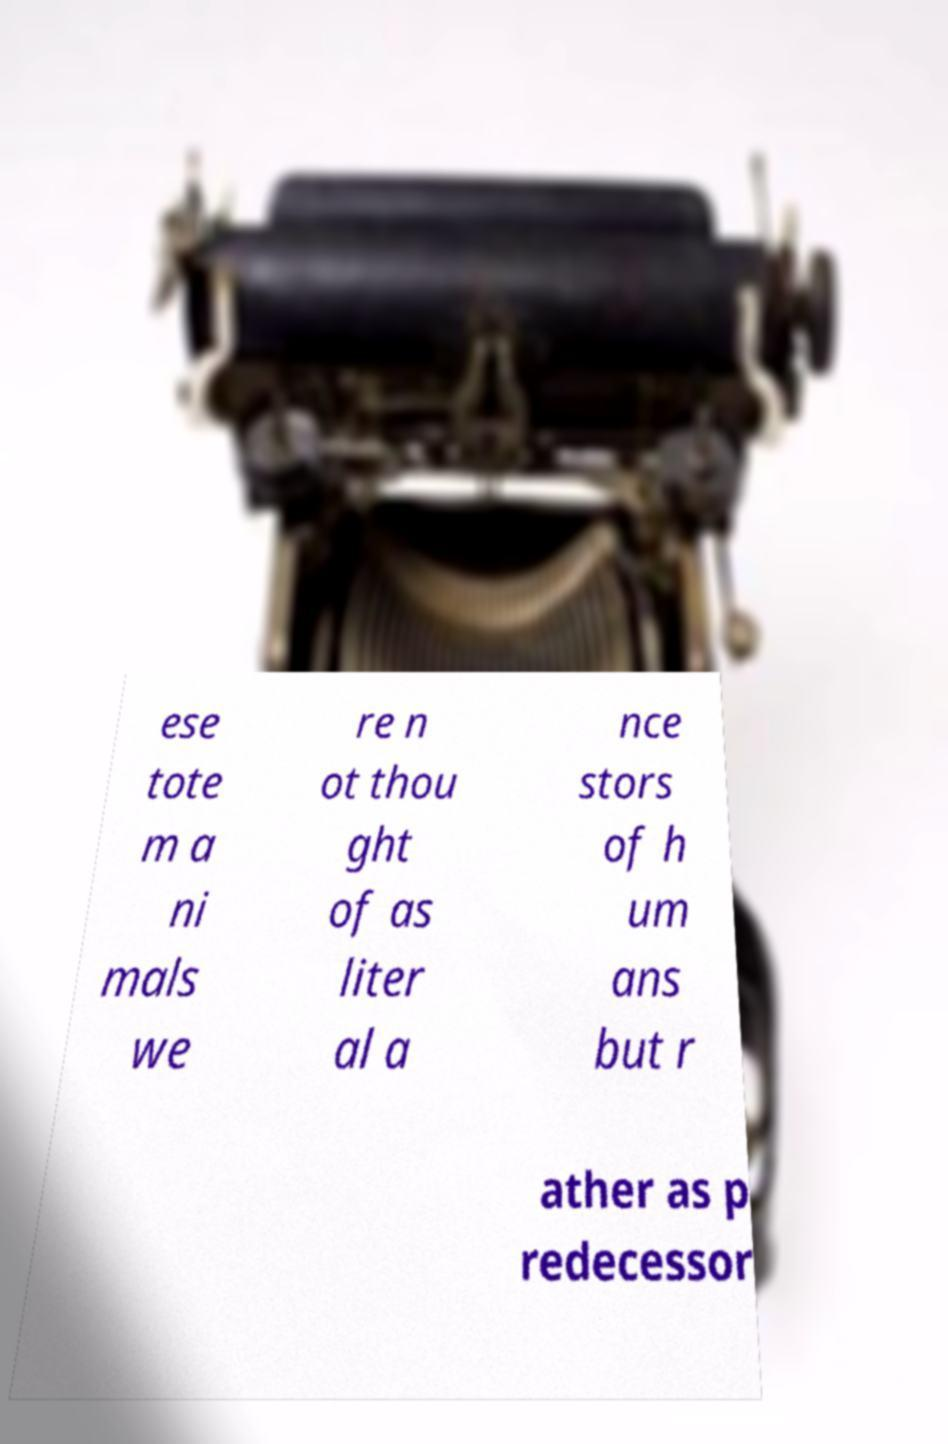There's text embedded in this image that I need extracted. Can you transcribe it verbatim? ese tote m a ni mals we re n ot thou ght of as liter al a nce stors of h um ans but r ather as p redecessor 